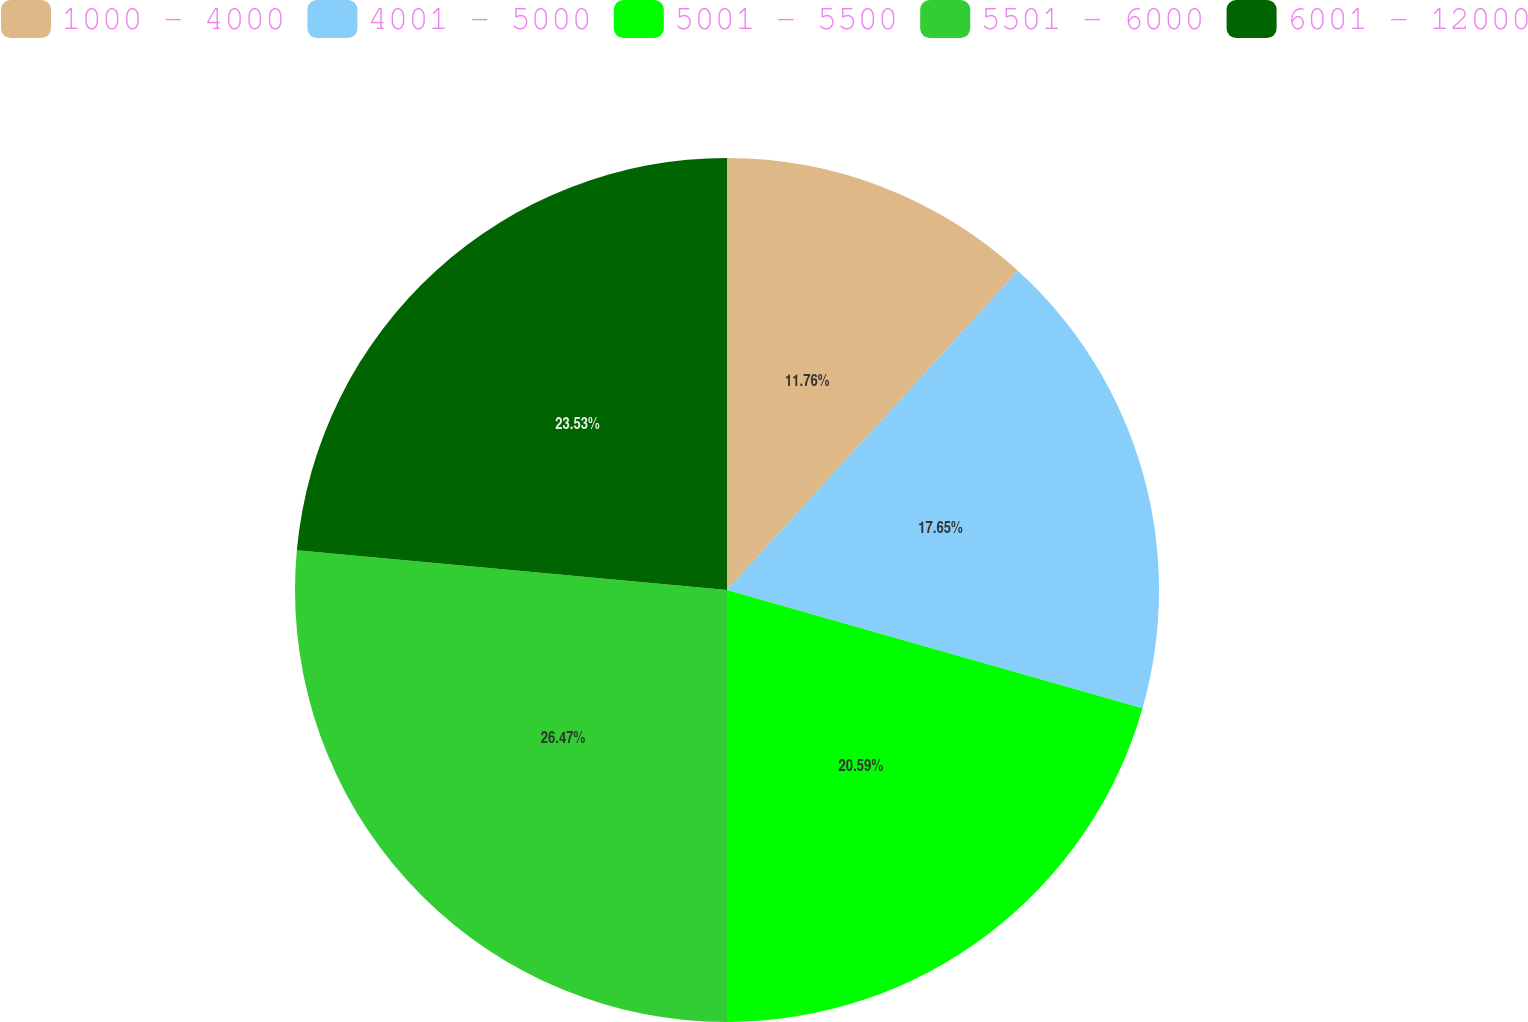Convert chart. <chart><loc_0><loc_0><loc_500><loc_500><pie_chart><fcel>1000 - 4000<fcel>4001 - 5000<fcel>5001 - 5500<fcel>5501 - 6000<fcel>6001 - 12000<nl><fcel>11.76%<fcel>17.65%<fcel>20.59%<fcel>26.47%<fcel>23.53%<nl></chart> 